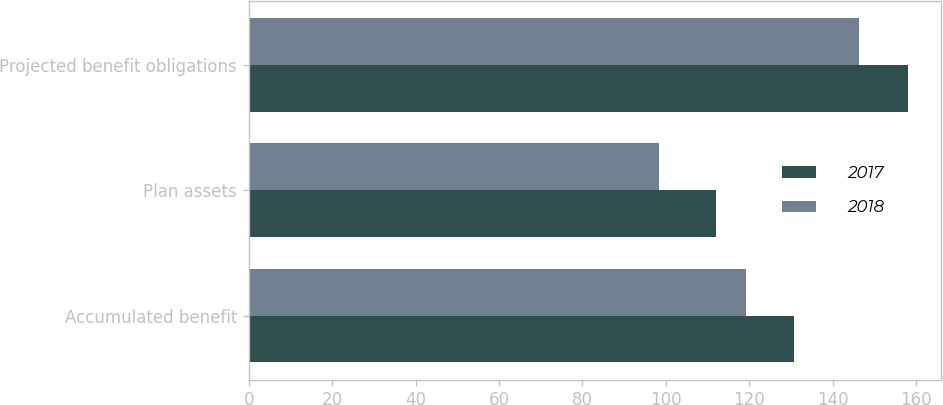Convert chart to OTSL. <chart><loc_0><loc_0><loc_500><loc_500><stacked_bar_chart><ecel><fcel>Accumulated benefit<fcel>Plan assets<fcel>Projected benefit obligations<nl><fcel>2017<fcel>130.7<fcel>112.1<fcel>158.1<nl><fcel>2018<fcel>119.2<fcel>98.3<fcel>146.4<nl></chart> 